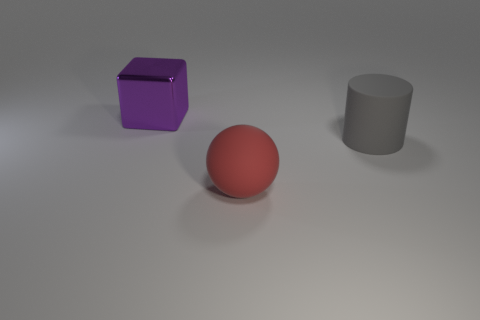Add 2 large yellow shiny blocks. How many objects exist? 5 Subtract all blocks. How many objects are left? 2 Add 1 big cylinders. How many big cylinders exist? 2 Subtract 1 gray cylinders. How many objects are left? 2 Subtract all big cyan metallic spheres. Subtract all large rubber cylinders. How many objects are left? 2 Add 3 red balls. How many red balls are left? 4 